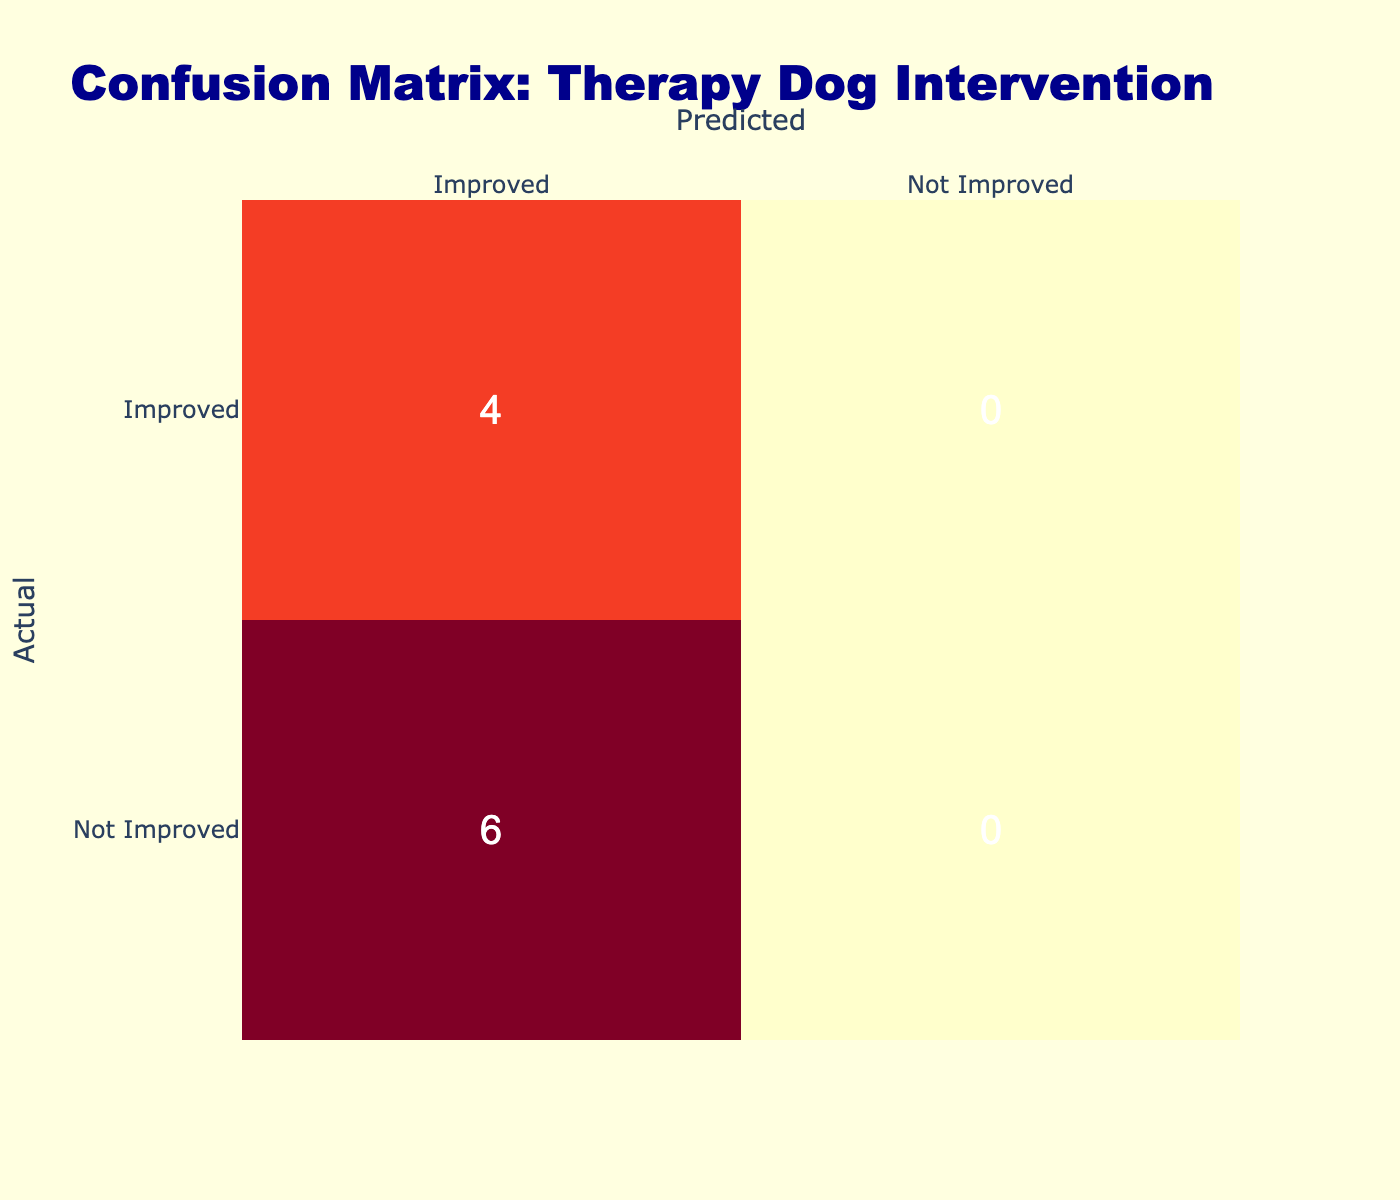What is the number of true positives in the confusion matrix? The true positives are found in the confusion matrix as those residents who were initially not improved in mobility (i.e., BeforeMobility is not 'Improved') and then indicated improvement (MobilityImprovement is 'Yes'). From the data, these cases are Resident 6, 3, 8, and 9. Therefore, the total count is 4.
Answer: 4 What is the number of false negatives recorded? False negatives are the residents who originally had limited or moderate mobility (BeforeMobility is not 'Improved') but did not show improvement (MobilityImprovement is 'No'). Reviewing the data, Residente 2, 4, and 5 fall into this category, which sums up to 3.
Answer: 3 How many total residents showed an improvement in mobility after therapy dog interventions? To find this, we look for all residents where MobilityImprovement is 'Yes'. The residents that fit this criteria are 1, 3, 6, 8, 9, and 10. Counting these residents gives us a total of 6.
Answer: 6 What percentage of residents had no improvement in mobility after the intervention? First, we determine the total number of residents, which is 10. Then, we find the number of residents who did not show improvement (MobilityImprovement is 'No'), which are Residents 2, 4, 5, and 7, totaling 4. The percentage of residents with no improvement is calculated as (4/10)*100 = 40%.
Answer: 40% Is it true that any resident with moderate mobility before the intervention did not show improvement afterward? By analyzing the data, we see that Residents 5 and 10 both had moderate mobility before the intervention. However, Resident 10 did improve, making the statement only partially true, as Resident 5 did not show improvement. Therefore, it can be concluded that yes, there is at least one resident with moderate mobility before the intervention who did not improve afterward.
Answer: Yes If we only consider residents with limited mobility before the intervention, how many of them improved afterward? From the information, residents 1, 2, and 4 had limited mobility before the intervention. Out of these, only Resident 1 showed improvement. Therefore, the count of residents with limited mobility who improved is 1.
Answer: 1 What is the difference between the number of true negatives and false positives? True negatives (TN) refer to residents who were predicted to have no improvement and actually had no improvement. According to the data, residents who fall into this category are Residents 7 and 5, totaling 2 true negatives. False positives (FP) are those predicted to have improvement but did not. The only resident fitting this is Resident 8, resulting in 1 false positive. Hence, the difference is 2 - 1 = 1.
Answer: 1 How many residents did not have 'Improved' mobility before the intervention? To answer this, we count the residents with either 'Limited' or 'Severe' mobility before the therapy, which includes Residents 1, 2, 4, 6, 7, and 9. In total, this gives us 6.
Answer: 6 